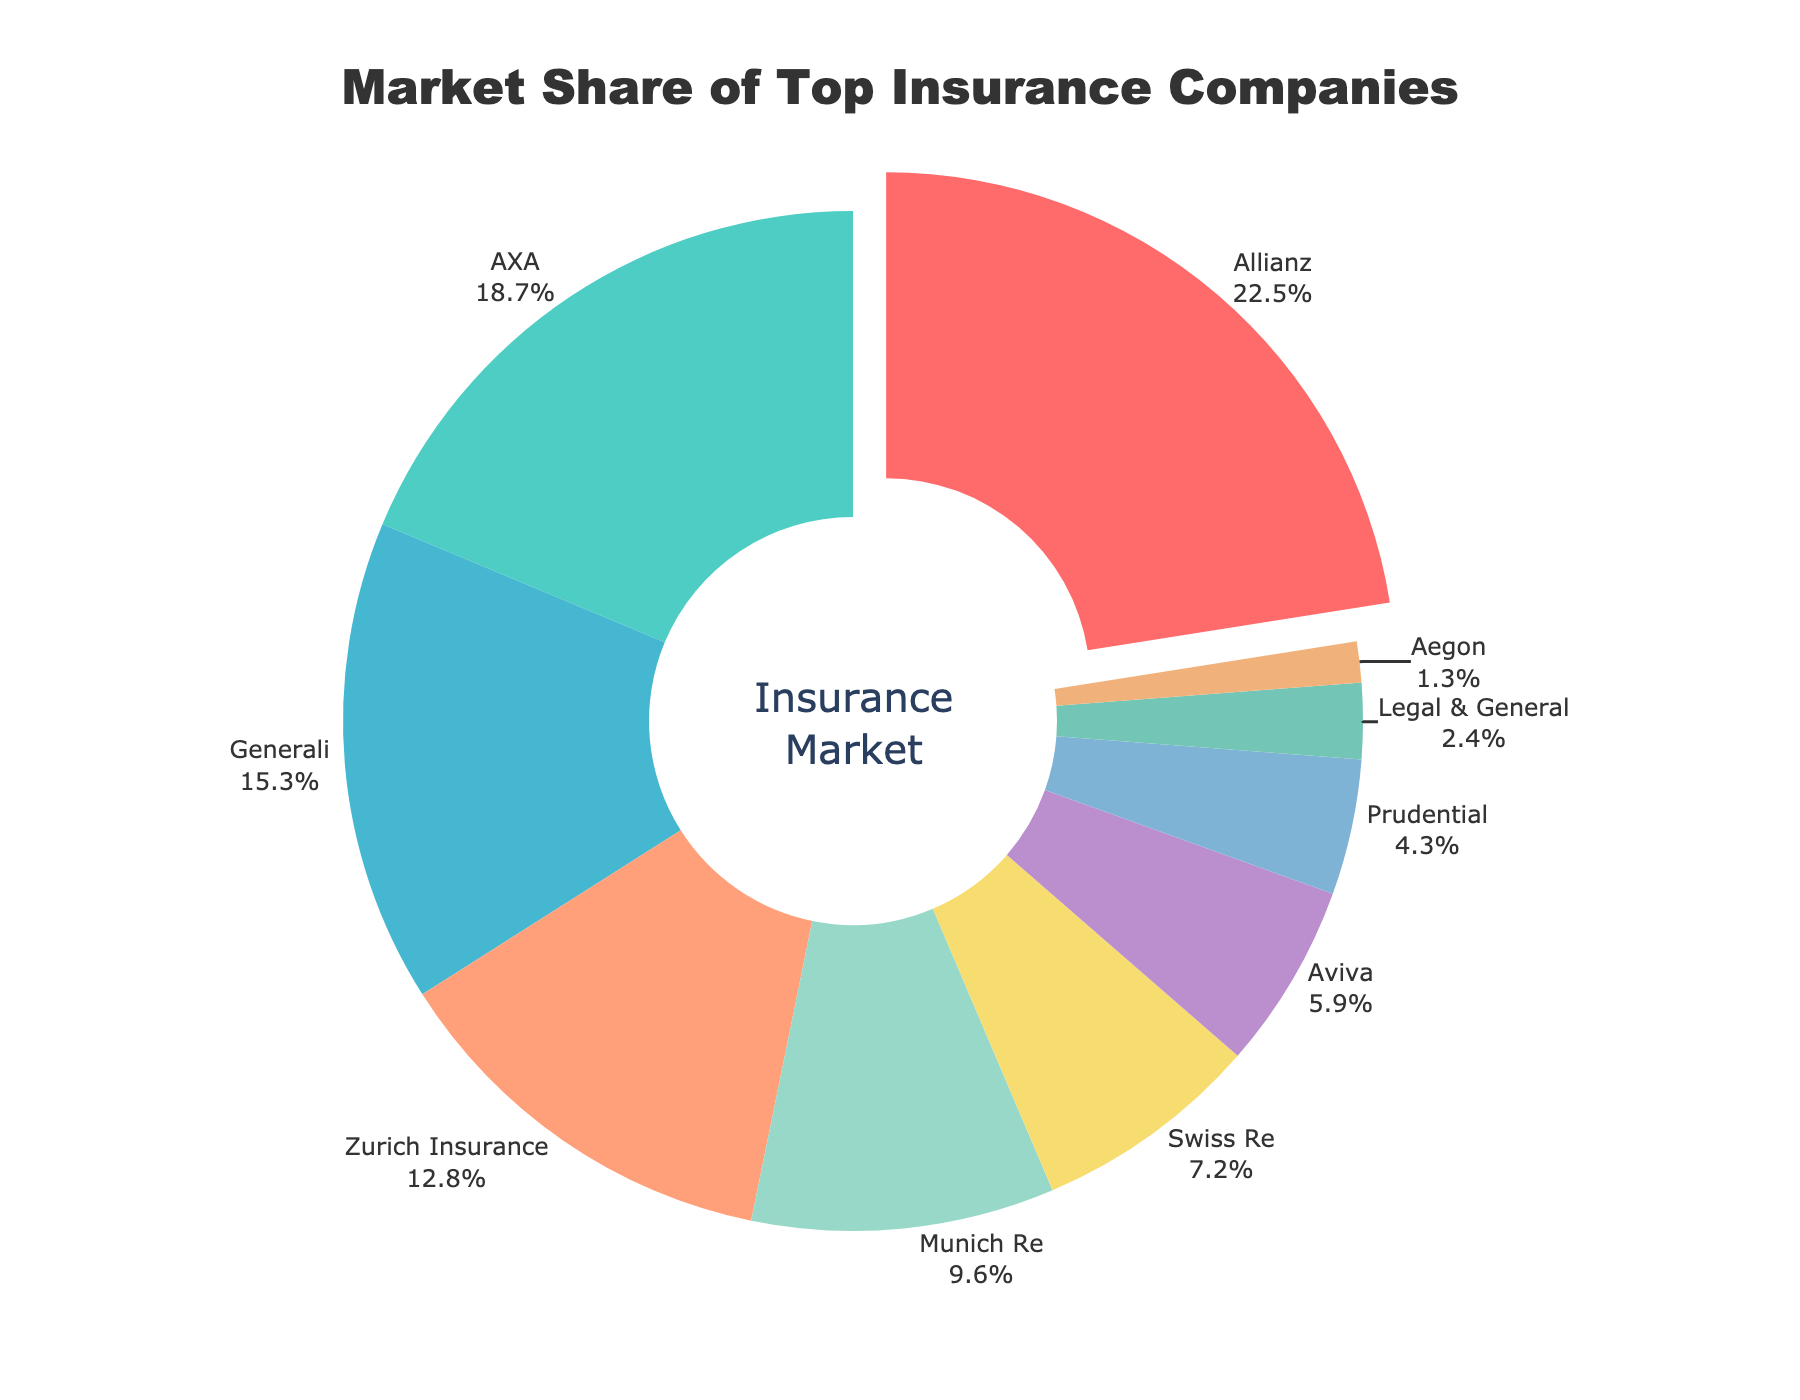What is the market share of Allianz? The figure shows that Allianz is the company with the highest market share. Finding its exact percentage from the visual data indicates that Allianz has a market share of 22.5%.
Answer: 22.5% Which company has the lowest market share? Checking the figure for the company with the smallest slice reveals that Aegon has the lowest market share. The percentage next to its label indicates a market share of 1.3%.
Answer: Aegon What is the combined market share of the top three companies? From the figure, the top three companies are Allianz, AXA, and Generali, with market shares of 22.5%, 18.7%, and 15.3% respectively. Adding them together gives 22.5 + 18.7 + 15.3 = 56.5%.
Answer: 56.5% How much greater is Allianz’s market share compared to Zurich Insurance? The figure shows Allianz's market share is 22.5% and Zurich Insurance’s is 12.8%. Subtracting these gives 22.5 - 12.8 = 9.7%.
Answer: 9.7% Which company has approximately half the market share of Allianz? Allianz's market share is 22.5%. Half of this is 22.5 / 2 = 11.25%. Checking the figure, Zurich Insurance closely matches this value with a market share of 12.8%.
Answer: Zurich Insurance Is there any company with a market share less than 5%? Observing the figure, the companies Prudential, Legal & General, and Aegon have market shares of 4.3%, 2.4%, and 1.3%, respectively. Each of these values is below 5%.
Answer: Yes Which company has more market share: Munich Re or Swiss Re? Referring to the visual data in the figure, Munich Re has a market share of 9.6%, while Swiss Re has 7.2%. Since 9.6% is greater than 7.2%, Munich Re has more market share.
Answer: Munich Re What is the average market share of Prudential, Legal & General, and Aegon? The market shares are Prudential 4.3%, Legal & General 2.4%, and Aegon 1.3%. Summing these up gives 4.3+2.4+1.3 = 8.0%. Dividing by 3 (since there are 3 companies) gives an average of 8.0 / 3 ≈ 2.67%.
Answer: ~2.67% What percentage of the market do Zurich Insurance and Munich Re together hold? The market share of Zurich Insurance is 12.8% and Munich Re is 9.6%. Summing these together gives 12.8 + 9.6 = 22.4%.
Answer: 22.4% Which company's market share is visually represented in red? Observing the colors in the figure, the segment colored in red corresponds to Allianz. Verifying the adjacent percentage label indicates Allianz's market share of 22.5%.
Answer: Allianz 